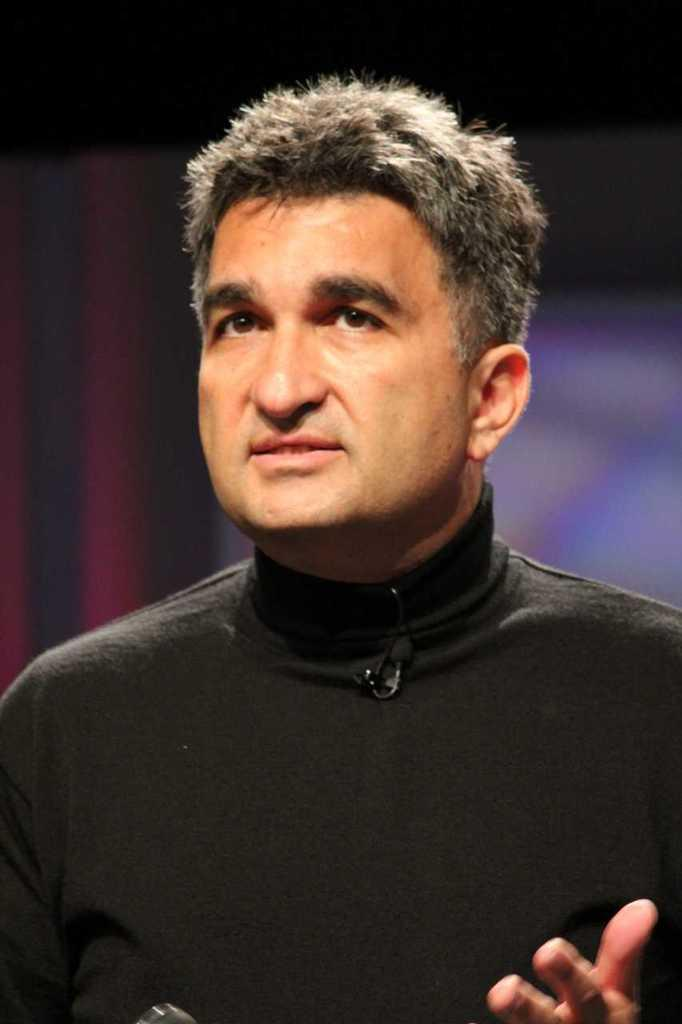What is the main subject of the image? There is a person in the image. What is the person wearing? The person is wearing a black dress. What is the person doing in the image? The person is talking. How would you describe the background of the image? The background of the image is dark and slightly blurred. What type of lace can be seen on the person's dress in the image? There is no lace visible on the person's dress in the image. What song is the person singing in the image? The image does not show the person singing, only talking. 